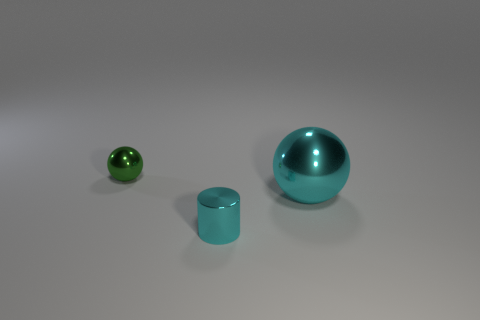There is a green shiny thing that is the same size as the cyan metallic cylinder; what shape is it?
Offer a terse response. Sphere. Is there a big rubber thing of the same color as the small ball?
Offer a very short reply. No. There is a thing left of the shiny cylinder; what shape is it?
Make the answer very short. Sphere. The big ball has what color?
Offer a very short reply. Cyan. There is a small cylinder that is made of the same material as the cyan ball; what is its color?
Keep it short and to the point. Cyan. What number of tiny cylinders have the same material as the small green sphere?
Your answer should be compact. 1. There is a green object; how many large metal balls are behind it?
Your answer should be compact. 0. Are the tiny object behind the large cyan metallic object and the large ball on the right side of the tiny sphere made of the same material?
Offer a terse response. Yes. Is the number of cyan shiny balls in front of the large ball greater than the number of big cyan spheres that are to the right of the small cyan cylinder?
Offer a very short reply. No. What material is the cylinder that is the same color as the big thing?
Your response must be concise. Metal. 